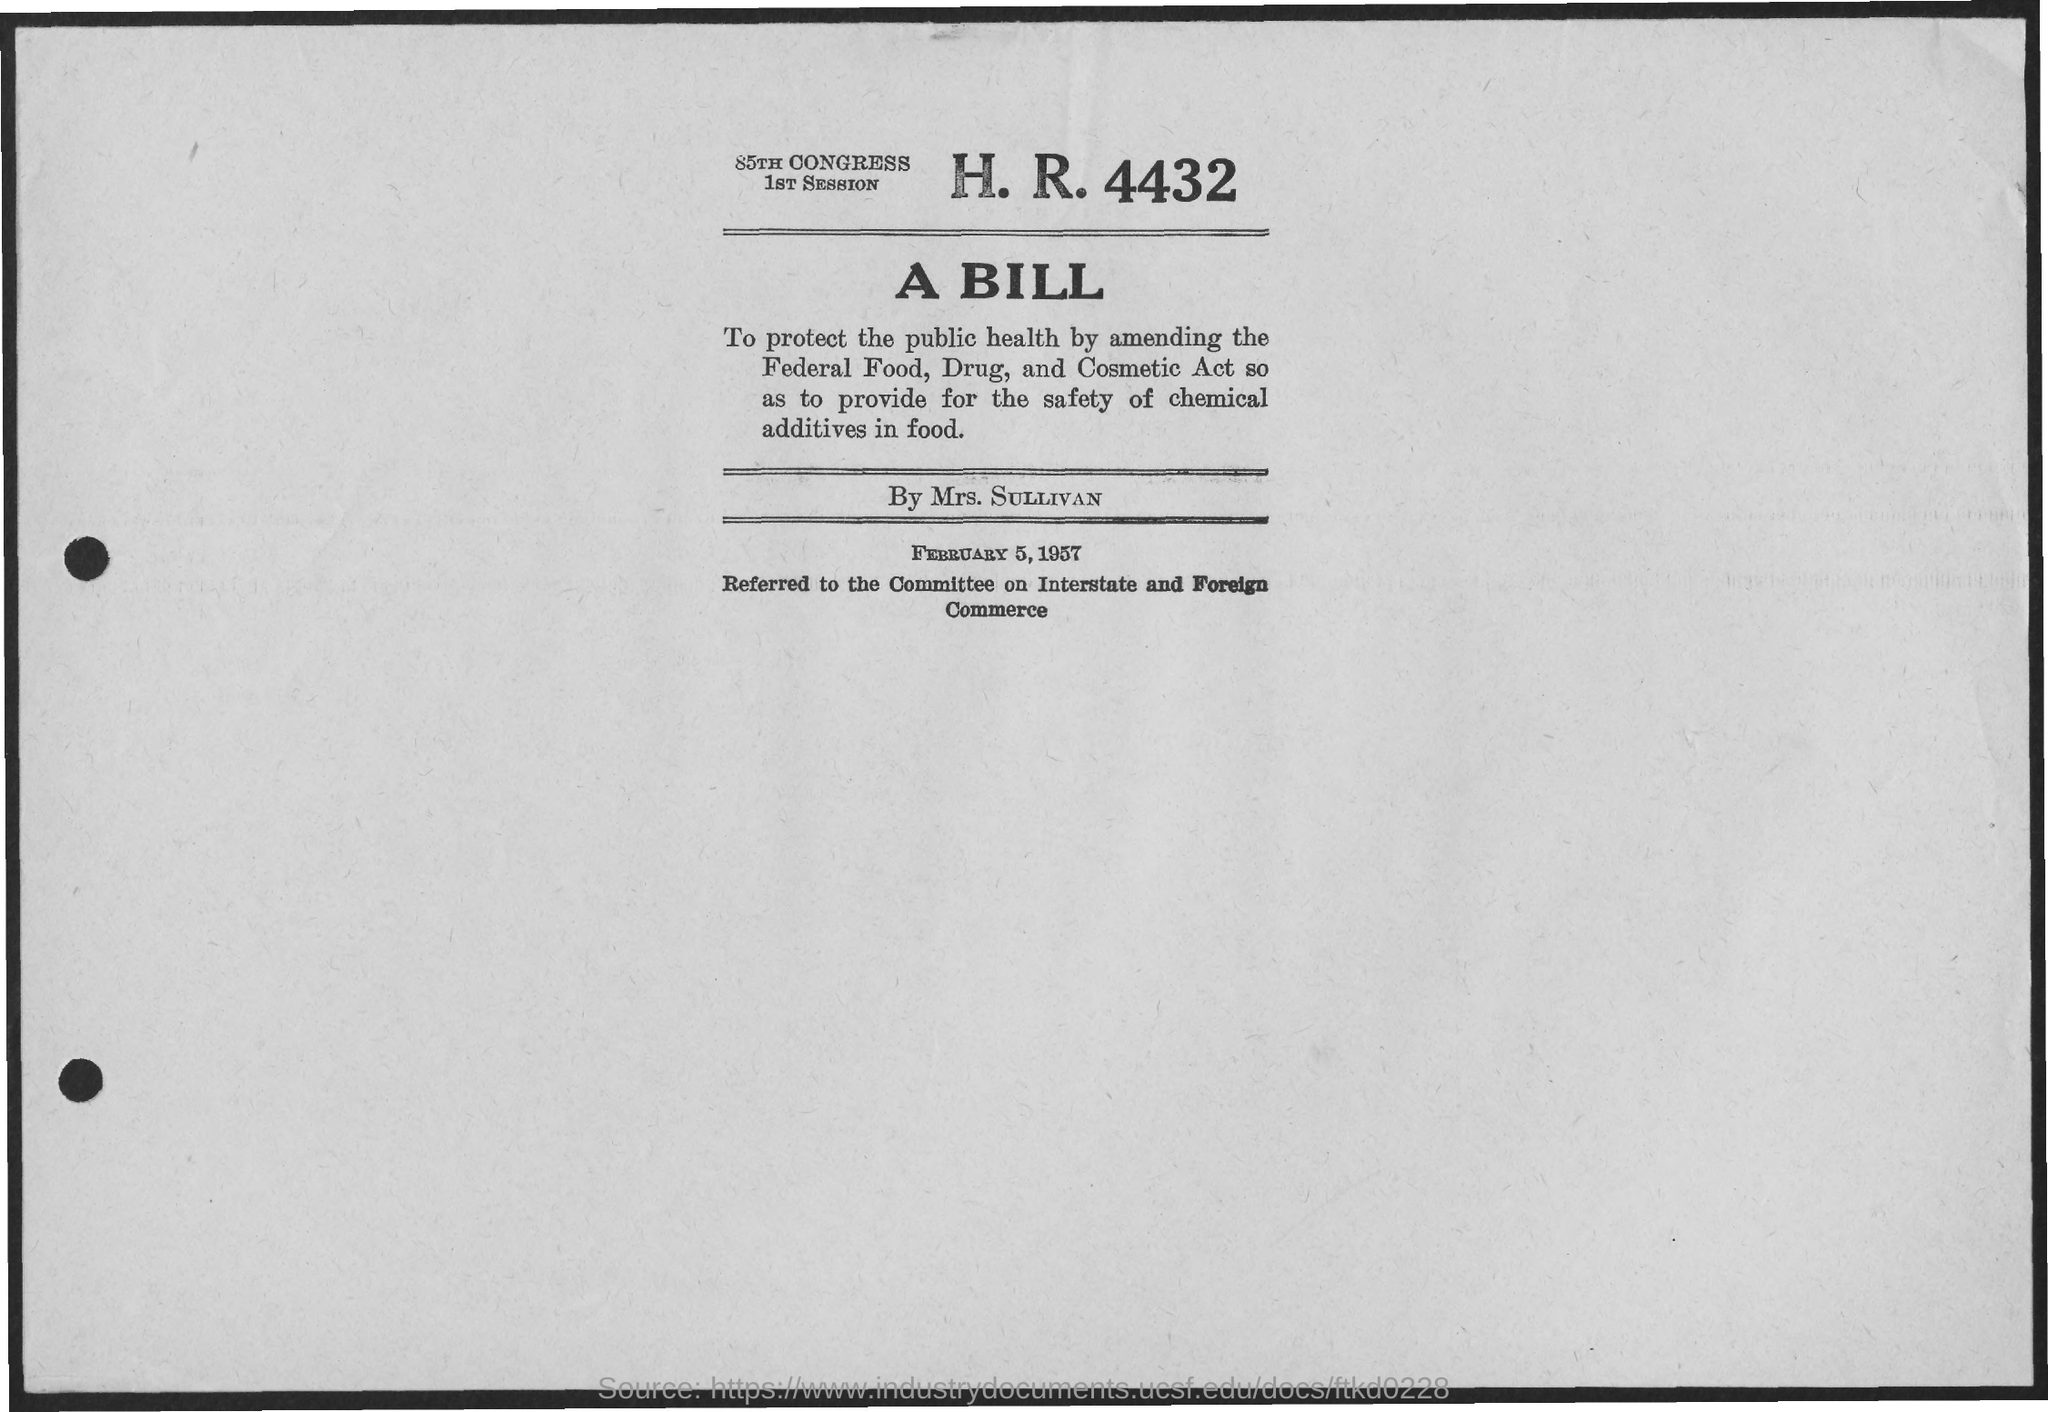List a handful of essential elements in this visual. The document indicates that the date is February 5, 1957. A bill was introduced by Mrs. SULLIVAN. 